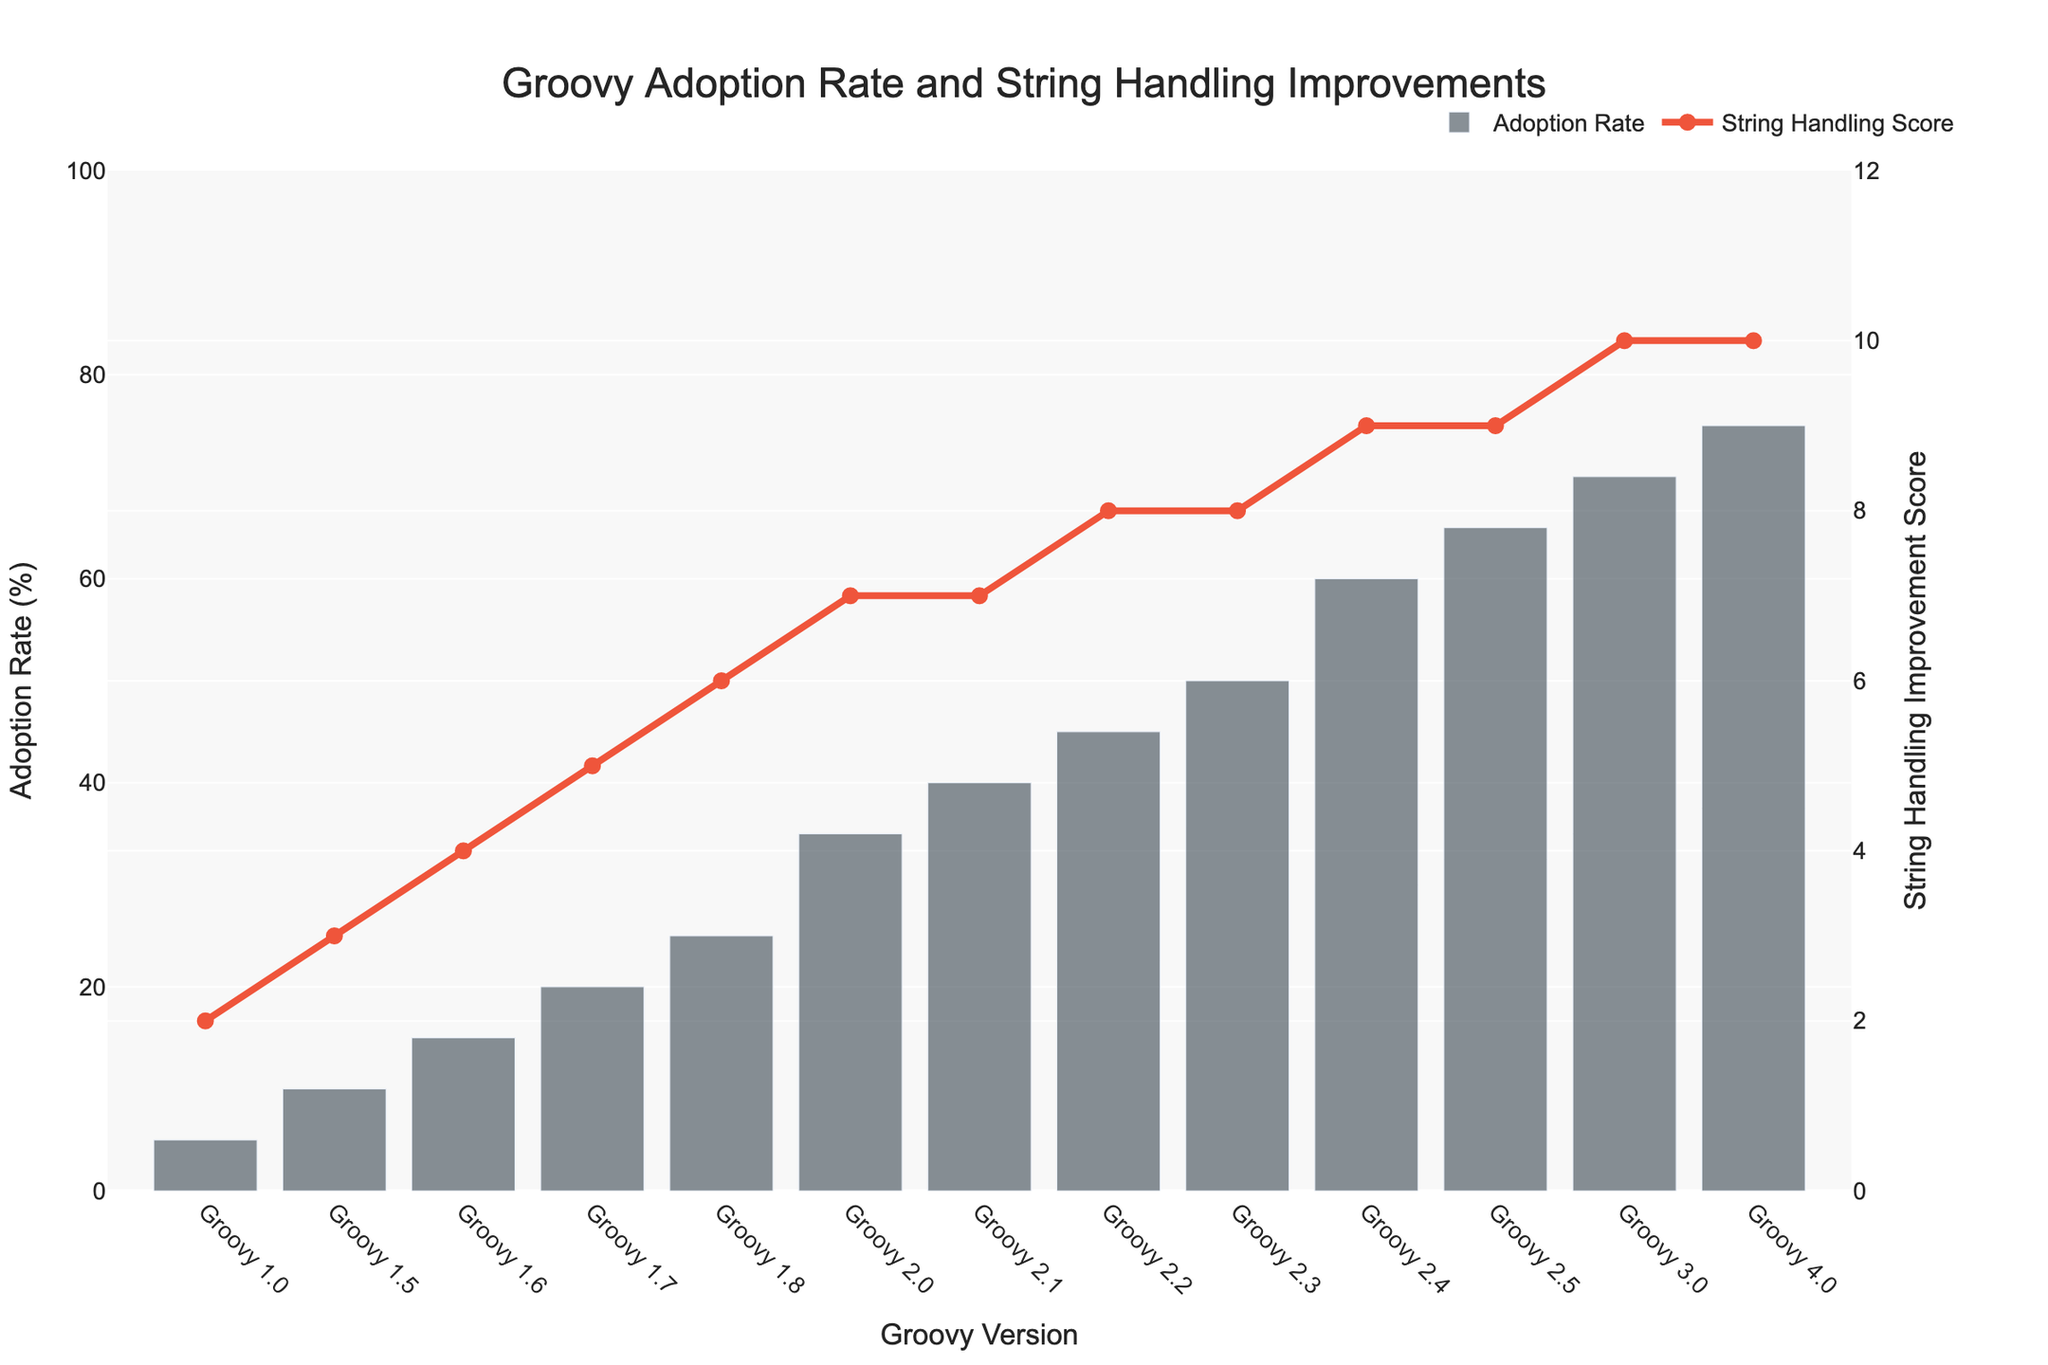What is the adoption rate of Groovy 2.0? The bar corresponding to Groovy 2.0 shows the adoption rate.
Answer: 35% Which Groovy version has the highest string handling improvement score? The highest point on the red line corresponds to Groovy 3.0 and Groovy 4.0.
Answer: Groovy 3.0 and Groovy 4.0 What is the difference in adoption rates between Groovy 1.0 and Groovy 4.0? Subtract the adoption rate of Groovy 1.0 from that of Groovy 4.0: 75 - 5 = 70.
Answer: 70% How does the adoption rate of Groovy 2.4 compare with Groovy 2.3? The bars show that Groovy 2.4 has a higher adoption rate than Groovy 2.3.
Answer: Groovy 2.4 has a higher adoption rate At which Groovy version did the adoption rate exceed 50%? The bar corresponding to Groovy 2.4 first exceeds 50%.
Answer: Groovy 2.4 Which Groovy versions share the same string handling improvement score? The string handling improvement scores on the line are the same for Groovy 3.0 and Groovy 4.0.
Answer: Groovy 3.0 and Groovy 4.0 How many versions have a string handling improvement score greater than or equal to 8? Count the versions with scores of 8, 9, or 10: Groovy 2.2, 2.3, 2.4, 2.5, 3.0, 4.0.
Answer: 6 versions What is the range of string handling improvement scores? The lowest score is 2 and the highest is 10, so the range is 10 - 2.
Answer: 8 Which version shows a sudden increase in both adoption rate and string handling improvement score? Both adoption rates and scores significantly increase from Groovy 1.7 to 2.0.
Answer: Groovy 2.0 Which Groovy versions have an adoption rate higher than 60%? Bars corresponding to Groovy 2.5, 3.0, and 4.0 are above 60.
Answer: Groovy 2.5, 3.0, 4.0 